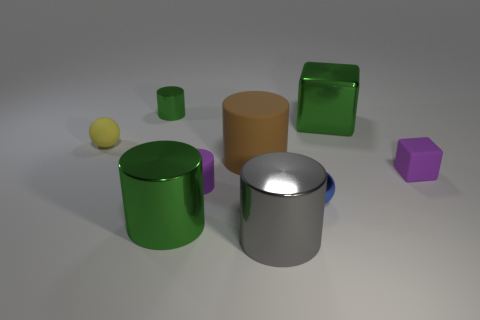Subtract all large green shiny cylinders. How many cylinders are left? 4 Subtract all yellow blocks. How many green cylinders are left? 2 Subtract 3 cylinders. How many cylinders are left? 2 Subtract all purple cylinders. How many cylinders are left? 4 Subtract all blocks. How many objects are left? 7 Subtract all gray cylinders. Subtract all brown blocks. How many cylinders are left? 4 Subtract all tiny spheres. Subtract all tiny blue matte cubes. How many objects are left? 7 Add 5 purple matte blocks. How many purple matte blocks are left? 6 Add 8 large matte cylinders. How many large matte cylinders exist? 9 Subtract 1 gray cylinders. How many objects are left? 8 